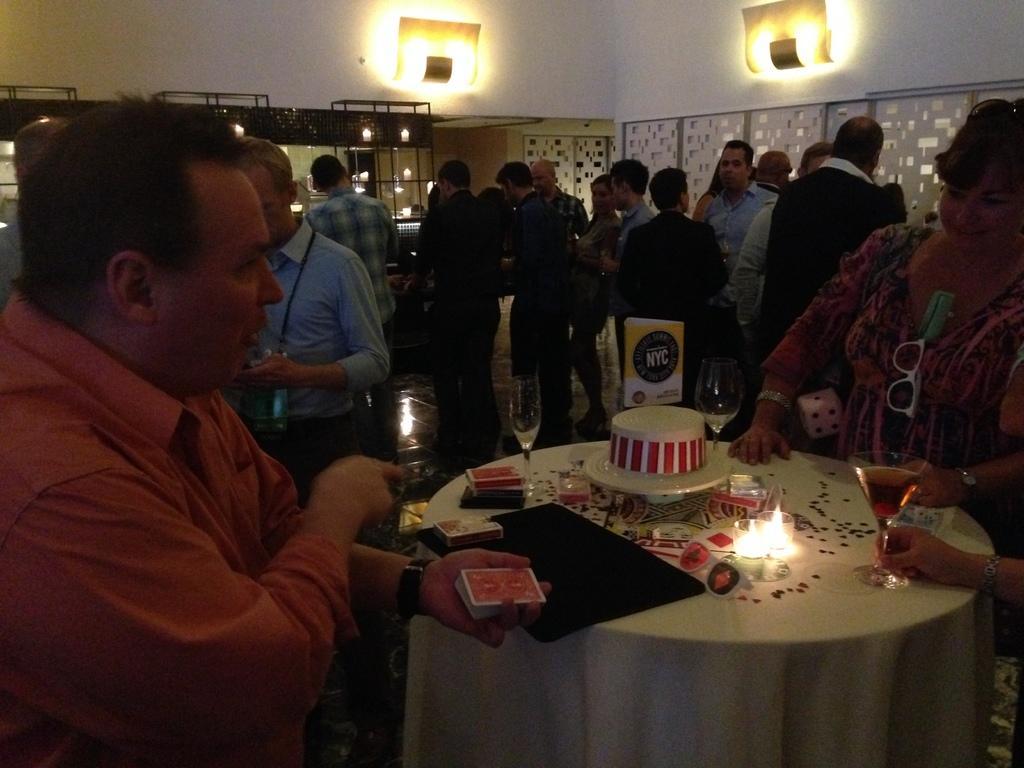Could you give a brief overview of what you see in this image? In the picture there are few people stood and in the front there is a table with candles and cake on it, on the right side there is woman and on left side there is a man. 